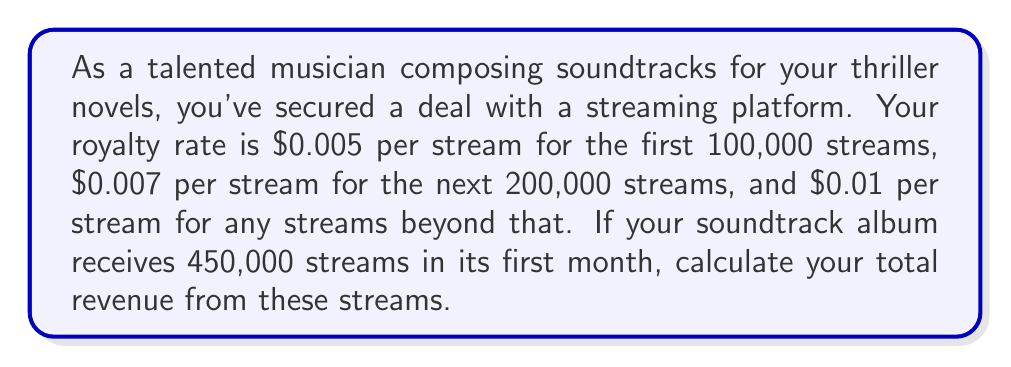Show me your answer to this math problem. Let's break this problem down into steps:

1. Calculate revenue for the first 100,000 streams:
   $$ R_1 = 100,000 \times $0.005 = $500 $$

2. Calculate revenue for the next 200,000 streams:
   $$ R_2 = 200,000 \times $0.007 = $1,400 $$

3. Calculate revenue for the remaining streams:
   Remaining streams = $450,000 - 100,000 - 200,000 = 150,000$
   $$ R_3 = 150,000 \times $0.01 = $1,500 $$

4. Sum up the total revenue:
   $$ R_{total} = R_1 + R_2 + R_3 $$
   $$ R_{total} = $500 + $1,400 + $1,500 = $3,400 $$

Therefore, your total revenue from 450,000 streams is $3,400.
Answer: $3,400 